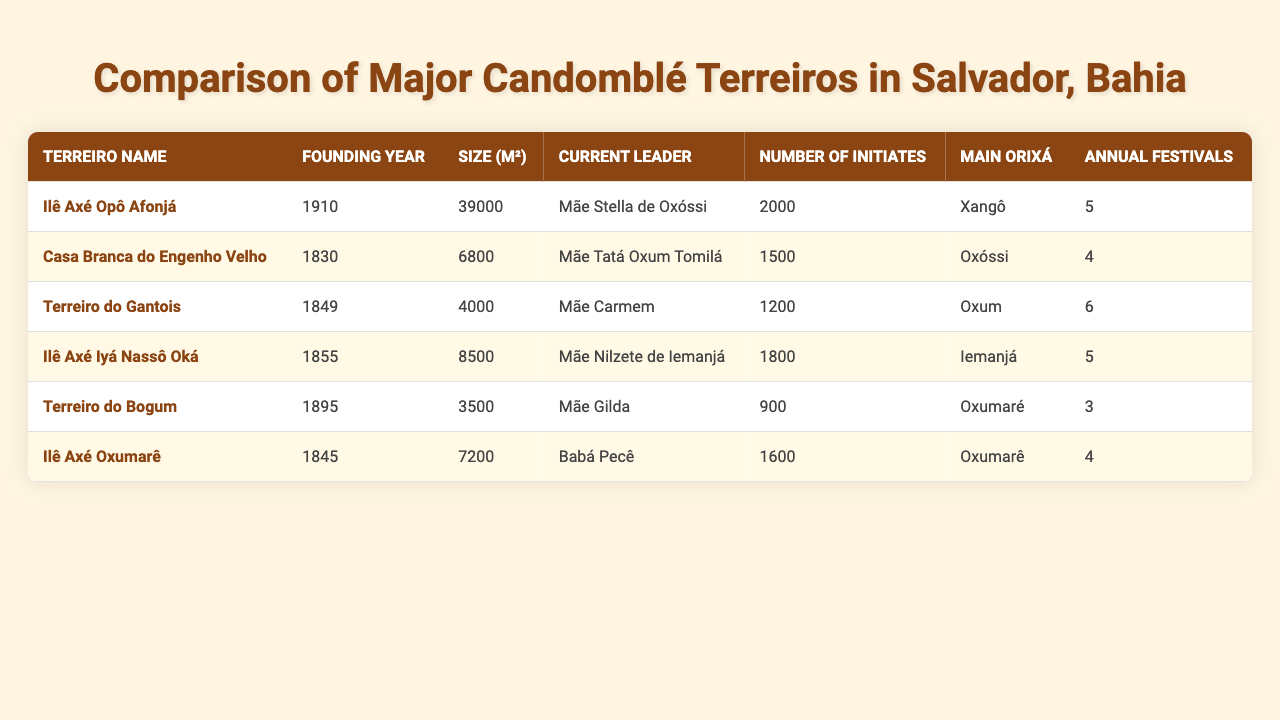What is the founding year of Ilê Axé Opô Afonjá? According to the table, Ilê Axé Opô Afonjá was founded in 1910.
Answer: 1910 Which terreiro has the largest size in square meters? The table indicates that Ilê Axé Opô Afonjá has the largest size at 39,000 square meters.
Answer: Ilê Axé Opô Afonjá How many annual festivals does Terreiro do Gantois have? The table shows that Terreiro do Gantois has 6 annual festivals.
Answer: 6 What is the average number of initiates across all terreiros? To find the average, sum the number of initiates (2000 + 1500 + 1200 + 1800 + 900 + 1600 = 8200) and divide by the number of terreiros (6). The average is 8200 / 6 ≈ 1366.67.
Answer: 1366.67 Is the main orixá of Casa Branca do Engenho Velho Oxóssi? The table confirms that the main orixá of Casa Branca do Engenho Velho is Oxóssi.
Answer: Yes Which terreiro has the smallest number of initiates? The table reveals that Terreiro do Bogum has the smallest number of initiates at 900.
Answer: Terreiro do Bogum What is the total size of all the terreiros combined? By summing the sizes of all terreiros (39000 + 6800 + 4000 + 8500 + 3500 + 7200 = 61000), we find the total size.
Answer: 61000 Who is the current leader of Ilê Axé Iyá Nassô Oká? The table states that the current leader of Ilê Axé Iyá Nassô Oká is Mãe Nilzete de Iemanjá.
Answer: Mãe Nilzete de Iemanjá What is the difference in the number of initiates between Ilê Axé Opô Afonjá and Terreiro do Bogum? The number of initiates for Ilê Axé Opô Afonjá is 2000 and for Terreiro do Bogum is 900. The difference is 2000 - 900 = 1100.
Answer: 1100 How many terreiros have 5 or more annual festivals? From the table, Ilê Axé Opô Afonjá, Terreiro do Gantois, and Ilê Axé Iyá Nassô Oká have 5 or more annual festivals. Therefore, there are 3 terreiros.
Answer: 3 